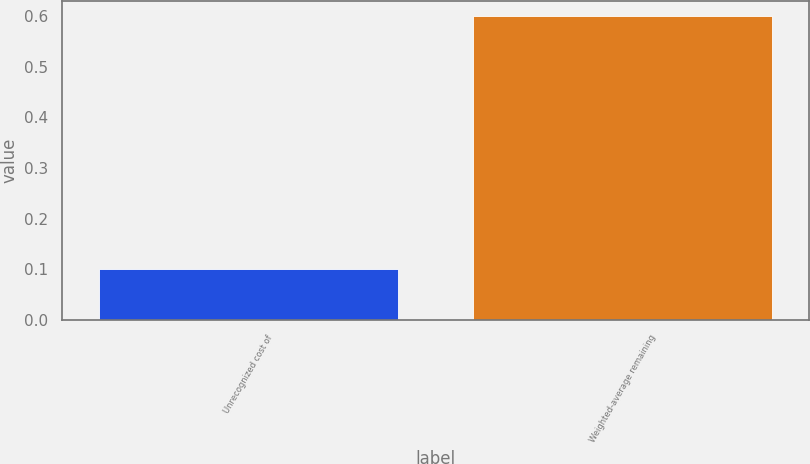<chart> <loc_0><loc_0><loc_500><loc_500><bar_chart><fcel>Unrecognized cost of<fcel>Weighted-average remaining<nl><fcel>0.1<fcel>0.6<nl></chart> 